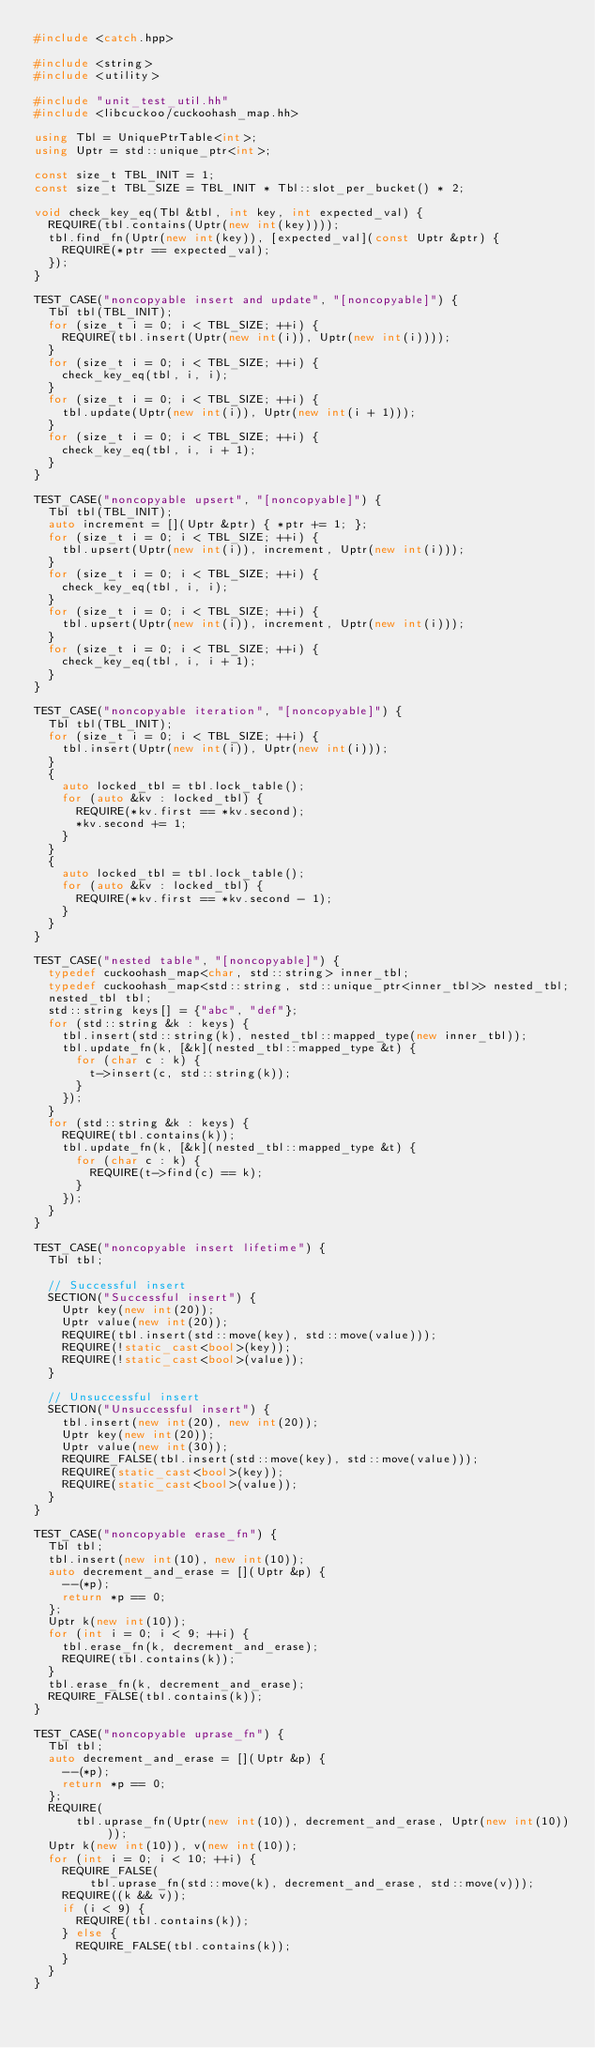Convert code to text. <code><loc_0><loc_0><loc_500><loc_500><_C++_>#include <catch.hpp>

#include <string>
#include <utility>

#include "unit_test_util.hh"
#include <libcuckoo/cuckoohash_map.hh>

using Tbl = UniquePtrTable<int>;
using Uptr = std::unique_ptr<int>;

const size_t TBL_INIT = 1;
const size_t TBL_SIZE = TBL_INIT * Tbl::slot_per_bucket() * 2;

void check_key_eq(Tbl &tbl, int key, int expected_val) {
  REQUIRE(tbl.contains(Uptr(new int(key))));
  tbl.find_fn(Uptr(new int(key)), [expected_val](const Uptr &ptr) {
    REQUIRE(*ptr == expected_val);
  });
}

TEST_CASE("noncopyable insert and update", "[noncopyable]") {
  Tbl tbl(TBL_INIT);
  for (size_t i = 0; i < TBL_SIZE; ++i) {
    REQUIRE(tbl.insert(Uptr(new int(i)), Uptr(new int(i))));
  }
  for (size_t i = 0; i < TBL_SIZE; ++i) {
    check_key_eq(tbl, i, i);
  }
  for (size_t i = 0; i < TBL_SIZE; ++i) {
    tbl.update(Uptr(new int(i)), Uptr(new int(i + 1)));
  }
  for (size_t i = 0; i < TBL_SIZE; ++i) {
    check_key_eq(tbl, i, i + 1);
  }
}

TEST_CASE("noncopyable upsert", "[noncopyable]") {
  Tbl tbl(TBL_INIT);
  auto increment = [](Uptr &ptr) { *ptr += 1; };
  for (size_t i = 0; i < TBL_SIZE; ++i) {
    tbl.upsert(Uptr(new int(i)), increment, Uptr(new int(i)));
  }
  for (size_t i = 0; i < TBL_SIZE; ++i) {
    check_key_eq(tbl, i, i);
  }
  for (size_t i = 0; i < TBL_SIZE; ++i) {
    tbl.upsert(Uptr(new int(i)), increment, Uptr(new int(i)));
  }
  for (size_t i = 0; i < TBL_SIZE; ++i) {
    check_key_eq(tbl, i, i + 1);
  }
}

TEST_CASE("noncopyable iteration", "[noncopyable]") {
  Tbl tbl(TBL_INIT);
  for (size_t i = 0; i < TBL_SIZE; ++i) {
    tbl.insert(Uptr(new int(i)), Uptr(new int(i)));
  }
  {
    auto locked_tbl = tbl.lock_table();
    for (auto &kv : locked_tbl) {
      REQUIRE(*kv.first == *kv.second);
      *kv.second += 1;
    }
  }
  {
    auto locked_tbl = tbl.lock_table();
    for (auto &kv : locked_tbl) {
      REQUIRE(*kv.first == *kv.second - 1);
    }
  }
}

TEST_CASE("nested table", "[noncopyable]") {
  typedef cuckoohash_map<char, std::string> inner_tbl;
  typedef cuckoohash_map<std::string, std::unique_ptr<inner_tbl>> nested_tbl;
  nested_tbl tbl;
  std::string keys[] = {"abc", "def"};
  for (std::string &k : keys) {
    tbl.insert(std::string(k), nested_tbl::mapped_type(new inner_tbl));
    tbl.update_fn(k, [&k](nested_tbl::mapped_type &t) {
      for (char c : k) {
        t->insert(c, std::string(k));
      }
    });
  }
  for (std::string &k : keys) {
    REQUIRE(tbl.contains(k));
    tbl.update_fn(k, [&k](nested_tbl::mapped_type &t) {
      for (char c : k) {
        REQUIRE(t->find(c) == k);
      }
    });
  }
}

TEST_CASE("noncopyable insert lifetime") {
  Tbl tbl;

  // Successful insert
  SECTION("Successful insert") {
    Uptr key(new int(20));
    Uptr value(new int(20));
    REQUIRE(tbl.insert(std::move(key), std::move(value)));
    REQUIRE(!static_cast<bool>(key));
    REQUIRE(!static_cast<bool>(value));
  }

  // Unsuccessful insert
  SECTION("Unsuccessful insert") {
    tbl.insert(new int(20), new int(20));
    Uptr key(new int(20));
    Uptr value(new int(30));
    REQUIRE_FALSE(tbl.insert(std::move(key), std::move(value)));
    REQUIRE(static_cast<bool>(key));
    REQUIRE(static_cast<bool>(value));
  }
}

TEST_CASE("noncopyable erase_fn") {
  Tbl tbl;
  tbl.insert(new int(10), new int(10));
  auto decrement_and_erase = [](Uptr &p) {
    --(*p);
    return *p == 0;
  };
  Uptr k(new int(10));
  for (int i = 0; i < 9; ++i) {
    tbl.erase_fn(k, decrement_and_erase);
    REQUIRE(tbl.contains(k));
  }
  tbl.erase_fn(k, decrement_and_erase);
  REQUIRE_FALSE(tbl.contains(k));
}

TEST_CASE("noncopyable uprase_fn") {
  Tbl tbl;
  auto decrement_and_erase = [](Uptr &p) {
    --(*p);
    return *p == 0;
  };
  REQUIRE(
      tbl.uprase_fn(Uptr(new int(10)), decrement_and_erase, Uptr(new int(10))));
  Uptr k(new int(10)), v(new int(10));
  for (int i = 0; i < 10; ++i) {
    REQUIRE_FALSE(
        tbl.uprase_fn(std::move(k), decrement_and_erase, std::move(v)));
    REQUIRE((k && v));
    if (i < 9) {
      REQUIRE(tbl.contains(k));
    } else {
      REQUIRE_FALSE(tbl.contains(k));
    }
  }
}
</code> 